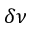<formula> <loc_0><loc_0><loc_500><loc_500>\delta \nu</formula> 